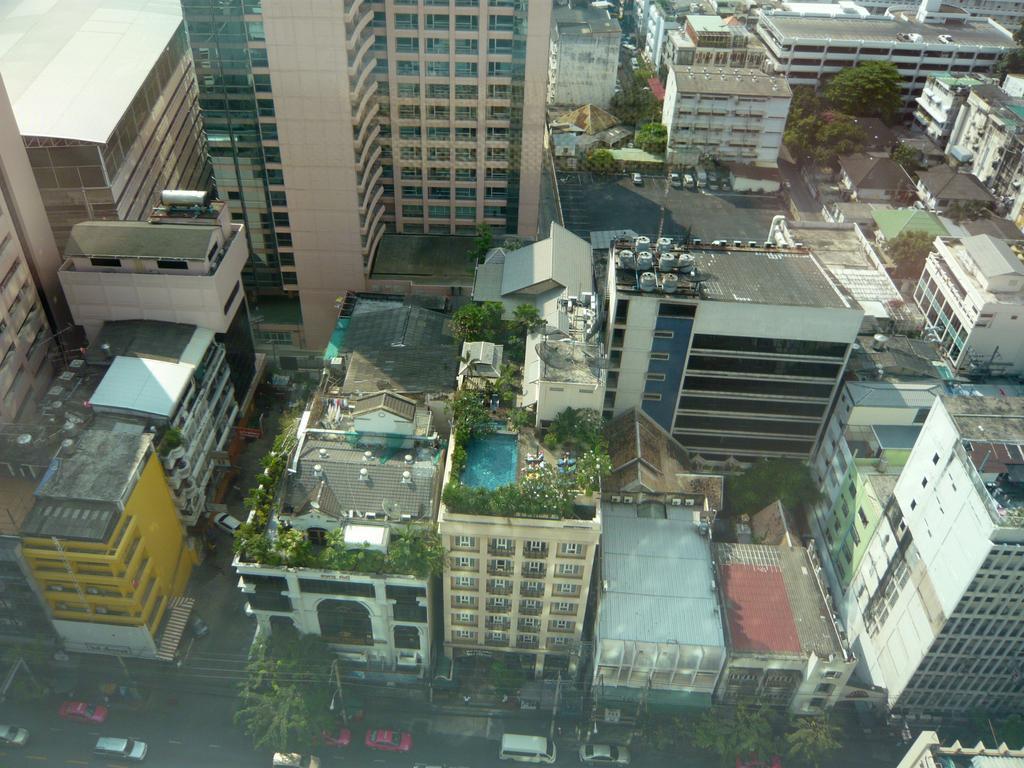In one or two sentences, can you explain what this image depicts? In this picture we can see few buildings, trees and few vehicles on the road, and also we can find a swimming pool on the building. 